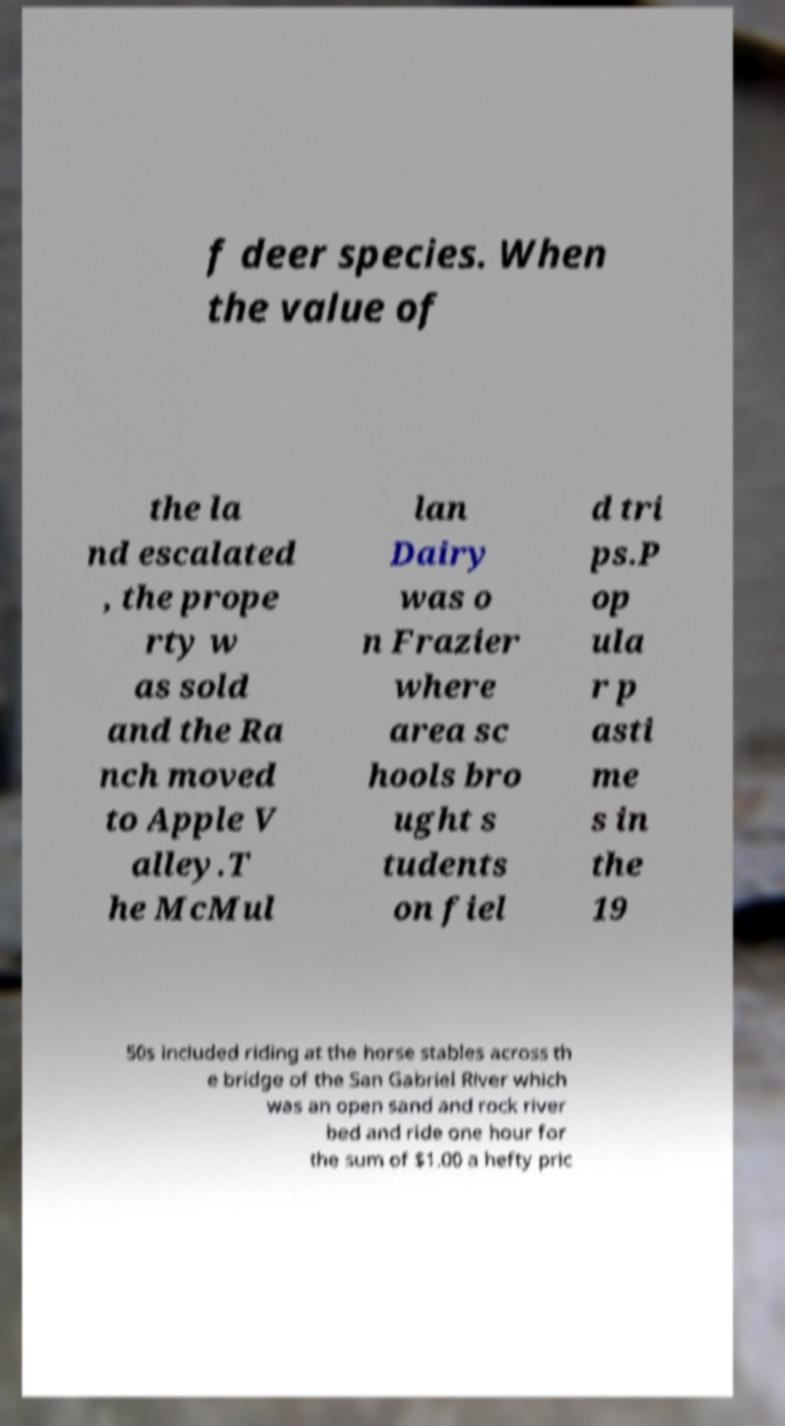Can you read and provide the text displayed in the image?This photo seems to have some interesting text. Can you extract and type it out for me? f deer species. When the value of the la nd escalated , the prope rty w as sold and the Ra nch moved to Apple V alley.T he McMul lan Dairy was o n Frazier where area sc hools bro ught s tudents on fiel d tri ps.P op ula r p asti me s in the 19 50s included riding at the horse stables across th e bridge of the San Gabriel River which was an open sand and rock river bed and ride one hour for the sum of $1.00 a hefty pric 